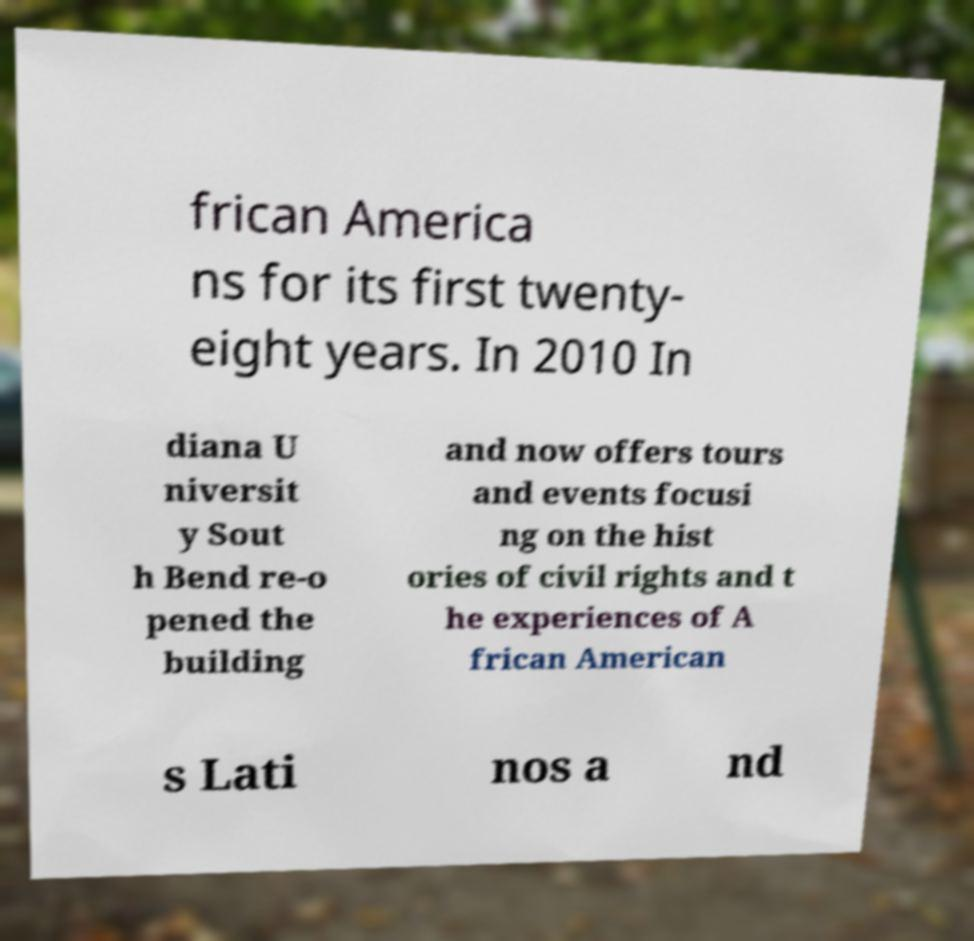What messages or text are displayed in this image? I need them in a readable, typed format. frican America ns for its first twenty- eight years. In 2010 In diana U niversit y Sout h Bend re-o pened the building and now offers tours and events focusi ng on the hist ories of civil rights and t he experiences of A frican American s Lati nos a nd 